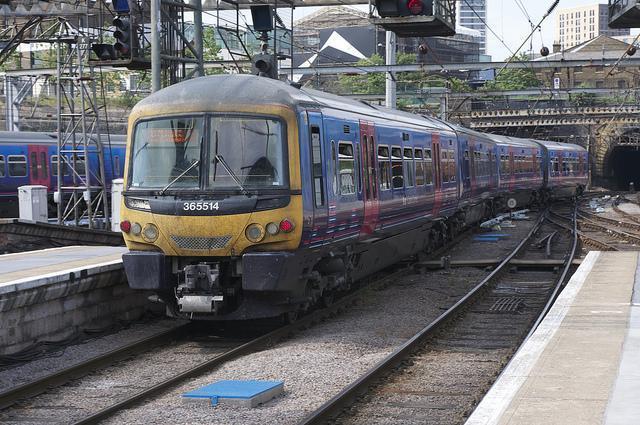How many trains can you see?
Give a very brief answer. 2. How many people in the picture?
Give a very brief answer. 0. 